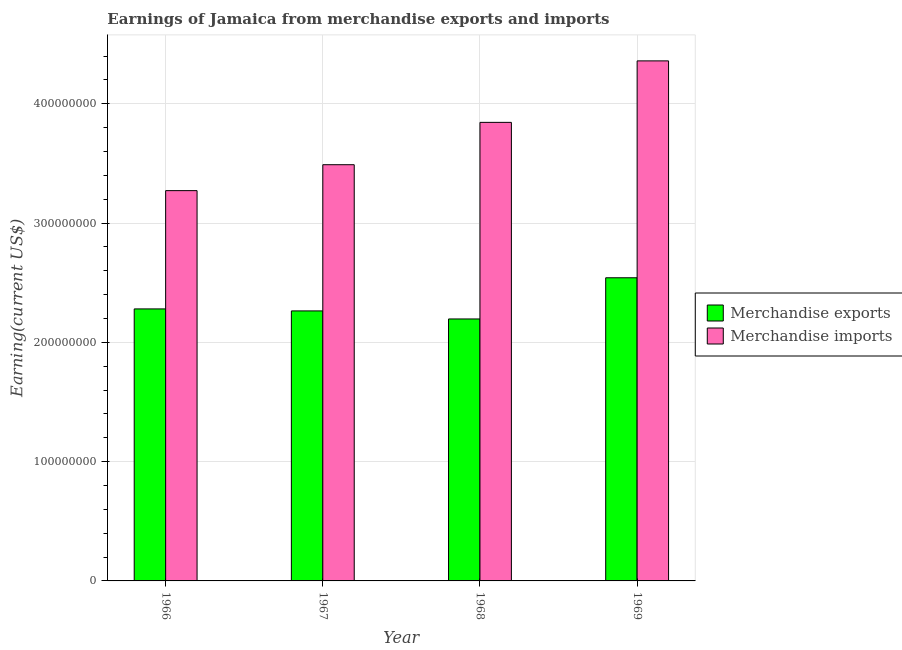How many groups of bars are there?
Your answer should be compact. 4. Are the number of bars per tick equal to the number of legend labels?
Your answer should be compact. Yes. How many bars are there on the 1st tick from the left?
Give a very brief answer. 2. How many bars are there on the 3rd tick from the right?
Provide a short and direct response. 2. What is the label of the 1st group of bars from the left?
Your response must be concise. 1966. What is the earnings from merchandise exports in 1968?
Ensure brevity in your answer.  2.20e+08. Across all years, what is the maximum earnings from merchandise exports?
Your response must be concise. 2.54e+08. Across all years, what is the minimum earnings from merchandise imports?
Your answer should be compact. 3.27e+08. In which year was the earnings from merchandise exports maximum?
Your answer should be compact. 1969. In which year was the earnings from merchandise imports minimum?
Your answer should be compact. 1966. What is the total earnings from merchandise imports in the graph?
Ensure brevity in your answer.  1.50e+09. What is the difference between the earnings from merchandise exports in 1966 and that in 1967?
Give a very brief answer. 1.68e+06. What is the difference between the earnings from merchandise exports in 1967 and the earnings from merchandise imports in 1966?
Your answer should be compact. -1.68e+06. What is the average earnings from merchandise imports per year?
Give a very brief answer. 3.74e+08. What is the ratio of the earnings from merchandise imports in 1968 to that in 1969?
Keep it short and to the point. 0.88. Is the difference between the earnings from merchandise imports in 1968 and 1969 greater than the difference between the earnings from merchandise exports in 1968 and 1969?
Make the answer very short. No. What is the difference between the highest and the second highest earnings from merchandise exports?
Your answer should be compact. 2.61e+07. What is the difference between the highest and the lowest earnings from merchandise exports?
Give a very brief answer. 3.45e+07. In how many years, is the earnings from merchandise imports greater than the average earnings from merchandise imports taken over all years?
Keep it short and to the point. 2. Is the sum of the earnings from merchandise exports in 1966 and 1967 greater than the maximum earnings from merchandise imports across all years?
Give a very brief answer. Yes. What is the title of the graph?
Provide a succinct answer. Earnings of Jamaica from merchandise exports and imports. What is the label or title of the Y-axis?
Your answer should be very brief. Earning(current US$). What is the Earning(current US$) in Merchandise exports in 1966?
Give a very brief answer. 2.28e+08. What is the Earning(current US$) of Merchandise imports in 1966?
Give a very brief answer. 3.27e+08. What is the Earning(current US$) in Merchandise exports in 1967?
Your answer should be very brief. 2.26e+08. What is the Earning(current US$) in Merchandise imports in 1967?
Ensure brevity in your answer.  3.49e+08. What is the Earning(current US$) of Merchandise exports in 1968?
Ensure brevity in your answer.  2.20e+08. What is the Earning(current US$) of Merchandise imports in 1968?
Provide a short and direct response. 3.84e+08. What is the Earning(current US$) of Merchandise exports in 1969?
Make the answer very short. 2.54e+08. What is the Earning(current US$) in Merchandise imports in 1969?
Your response must be concise. 4.36e+08. Across all years, what is the maximum Earning(current US$) of Merchandise exports?
Ensure brevity in your answer.  2.54e+08. Across all years, what is the maximum Earning(current US$) in Merchandise imports?
Your response must be concise. 4.36e+08. Across all years, what is the minimum Earning(current US$) in Merchandise exports?
Give a very brief answer. 2.20e+08. Across all years, what is the minimum Earning(current US$) of Merchandise imports?
Give a very brief answer. 3.27e+08. What is the total Earning(current US$) of Merchandise exports in the graph?
Your response must be concise. 9.28e+08. What is the total Earning(current US$) in Merchandise imports in the graph?
Provide a succinct answer. 1.50e+09. What is the difference between the Earning(current US$) of Merchandise exports in 1966 and that in 1967?
Your answer should be very brief. 1.68e+06. What is the difference between the Earning(current US$) in Merchandise imports in 1966 and that in 1967?
Offer a very short reply. -2.17e+07. What is the difference between the Earning(current US$) of Merchandise exports in 1966 and that in 1968?
Ensure brevity in your answer.  8.42e+06. What is the difference between the Earning(current US$) in Merchandise imports in 1966 and that in 1968?
Ensure brevity in your answer.  -5.72e+07. What is the difference between the Earning(current US$) of Merchandise exports in 1966 and that in 1969?
Provide a short and direct response. -2.61e+07. What is the difference between the Earning(current US$) of Merchandise imports in 1966 and that in 1969?
Your answer should be compact. -1.09e+08. What is the difference between the Earning(current US$) of Merchandise exports in 1967 and that in 1968?
Keep it short and to the point. 6.74e+06. What is the difference between the Earning(current US$) of Merchandise imports in 1967 and that in 1968?
Ensure brevity in your answer.  -3.55e+07. What is the difference between the Earning(current US$) in Merchandise exports in 1967 and that in 1969?
Offer a very short reply. -2.78e+07. What is the difference between the Earning(current US$) in Merchandise imports in 1967 and that in 1969?
Your answer should be very brief. -8.70e+07. What is the difference between the Earning(current US$) of Merchandise exports in 1968 and that in 1969?
Your response must be concise. -3.45e+07. What is the difference between the Earning(current US$) of Merchandise imports in 1968 and that in 1969?
Ensure brevity in your answer.  -5.15e+07. What is the difference between the Earning(current US$) of Merchandise exports in 1966 and the Earning(current US$) of Merchandise imports in 1967?
Your answer should be very brief. -1.21e+08. What is the difference between the Earning(current US$) in Merchandise exports in 1966 and the Earning(current US$) in Merchandise imports in 1968?
Your answer should be very brief. -1.56e+08. What is the difference between the Earning(current US$) of Merchandise exports in 1966 and the Earning(current US$) of Merchandise imports in 1969?
Offer a very short reply. -2.08e+08. What is the difference between the Earning(current US$) in Merchandise exports in 1967 and the Earning(current US$) in Merchandise imports in 1968?
Offer a very short reply. -1.58e+08. What is the difference between the Earning(current US$) in Merchandise exports in 1967 and the Earning(current US$) in Merchandise imports in 1969?
Offer a very short reply. -2.10e+08. What is the difference between the Earning(current US$) of Merchandise exports in 1968 and the Earning(current US$) of Merchandise imports in 1969?
Make the answer very short. -2.16e+08. What is the average Earning(current US$) of Merchandise exports per year?
Keep it short and to the point. 2.32e+08. What is the average Earning(current US$) of Merchandise imports per year?
Provide a short and direct response. 3.74e+08. In the year 1966, what is the difference between the Earning(current US$) of Merchandise exports and Earning(current US$) of Merchandise imports?
Ensure brevity in your answer.  -9.92e+07. In the year 1967, what is the difference between the Earning(current US$) of Merchandise exports and Earning(current US$) of Merchandise imports?
Your answer should be compact. -1.23e+08. In the year 1968, what is the difference between the Earning(current US$) in Merchandise exports and Earning(current US$) in Merchandise imports?
Your response must be concise. -1.65e+08. In the year 1969, what is the difference between the Earning(current US$) of Merchandise exports and Earning(current US$) of Merchandise imports?
Provide a succinct answer. -1.82e+08. What is the ratio of the Earning(current US$) in Merchandise exports in 1966 to that in 1967?
Give a very brief answer. 1.01. What is the ratio of the Earning(current US$) in Merchandise imports in 1966 to that in 1967?
Provide a succinct answer. 0.94. What is the ratio of the Earning(current US$) of Merchandise exports in 1966 to that in 1968?
Provide a short and direct response. 1.04. What is the ratio of the Earning(current US$) of Merchandise imports in 1966 to that in 1968?
Keep it short and to the point. 0.85. What is the ratio of the Earning(current US$) in Merchandise exports in 1966 to that in 1969?
Provide a short and direct response. 0.9. What is the ratio of the Earning(current US$) in Merchandise imports in 1966 to that in 1969?
Your answer should be very brief. 0.75. What is the ratio of the Earning(current US$) in Merchandise exports in 1967 to that in 1968?
Ensure brevity in your answer.  1.03. What is the ratio of the Earning(current US$) in Merchandise imports in 1967 to that in 1968?
Keep it short and to the point. 0.91. What is the ratio of the Earning(current US$) in Merchandise exports in 1967 to that in 1969?
Ensure brevity in your answer.  0.89. What is the ratio of the Earning(current US$) of Merchandise imports in 1967 to that in 1969?
Ensure brevity in your answer.  0.8. What is the ratio of the Earning(current US$) in Merchandise exports in 1968 to that in 1969?
Your response must be concise. 0.86. What is the ratio of the Earning(current US$) in Merchandise imports in 1968 to that in 1969?
Keep it short and to the point. 0.88. What is the difference between the highest and the second highest Earning(current US$) in Merchandise exports?
Your answer should be compact. 2.61e+07. What is the difference between the highest and the second highest Earning(current US$) of Merchandise imports?
Make the answer very short. 5.15e+07. What is the difference between the highest and the lowest Earning(current US$) in Merchandise exports?
Provide a succinct answer. 3.45e+07. What is the difference between the highest and the lowest Earning(current US$) of Merchandise imports?
Provide a short and direct response. 1.09e+08. 